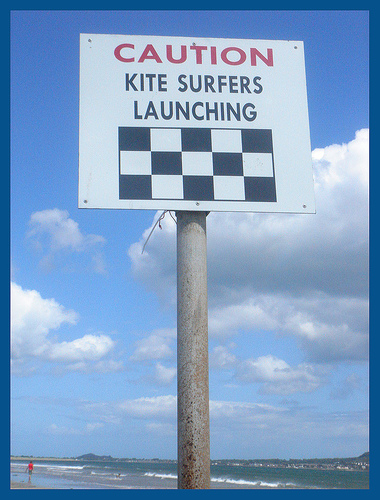<image>
Can you confirm if the wire is behind the board? Yes. From this viewpoint, the wire is positioned behind the board, with the board partially or fully occluding the wire. 